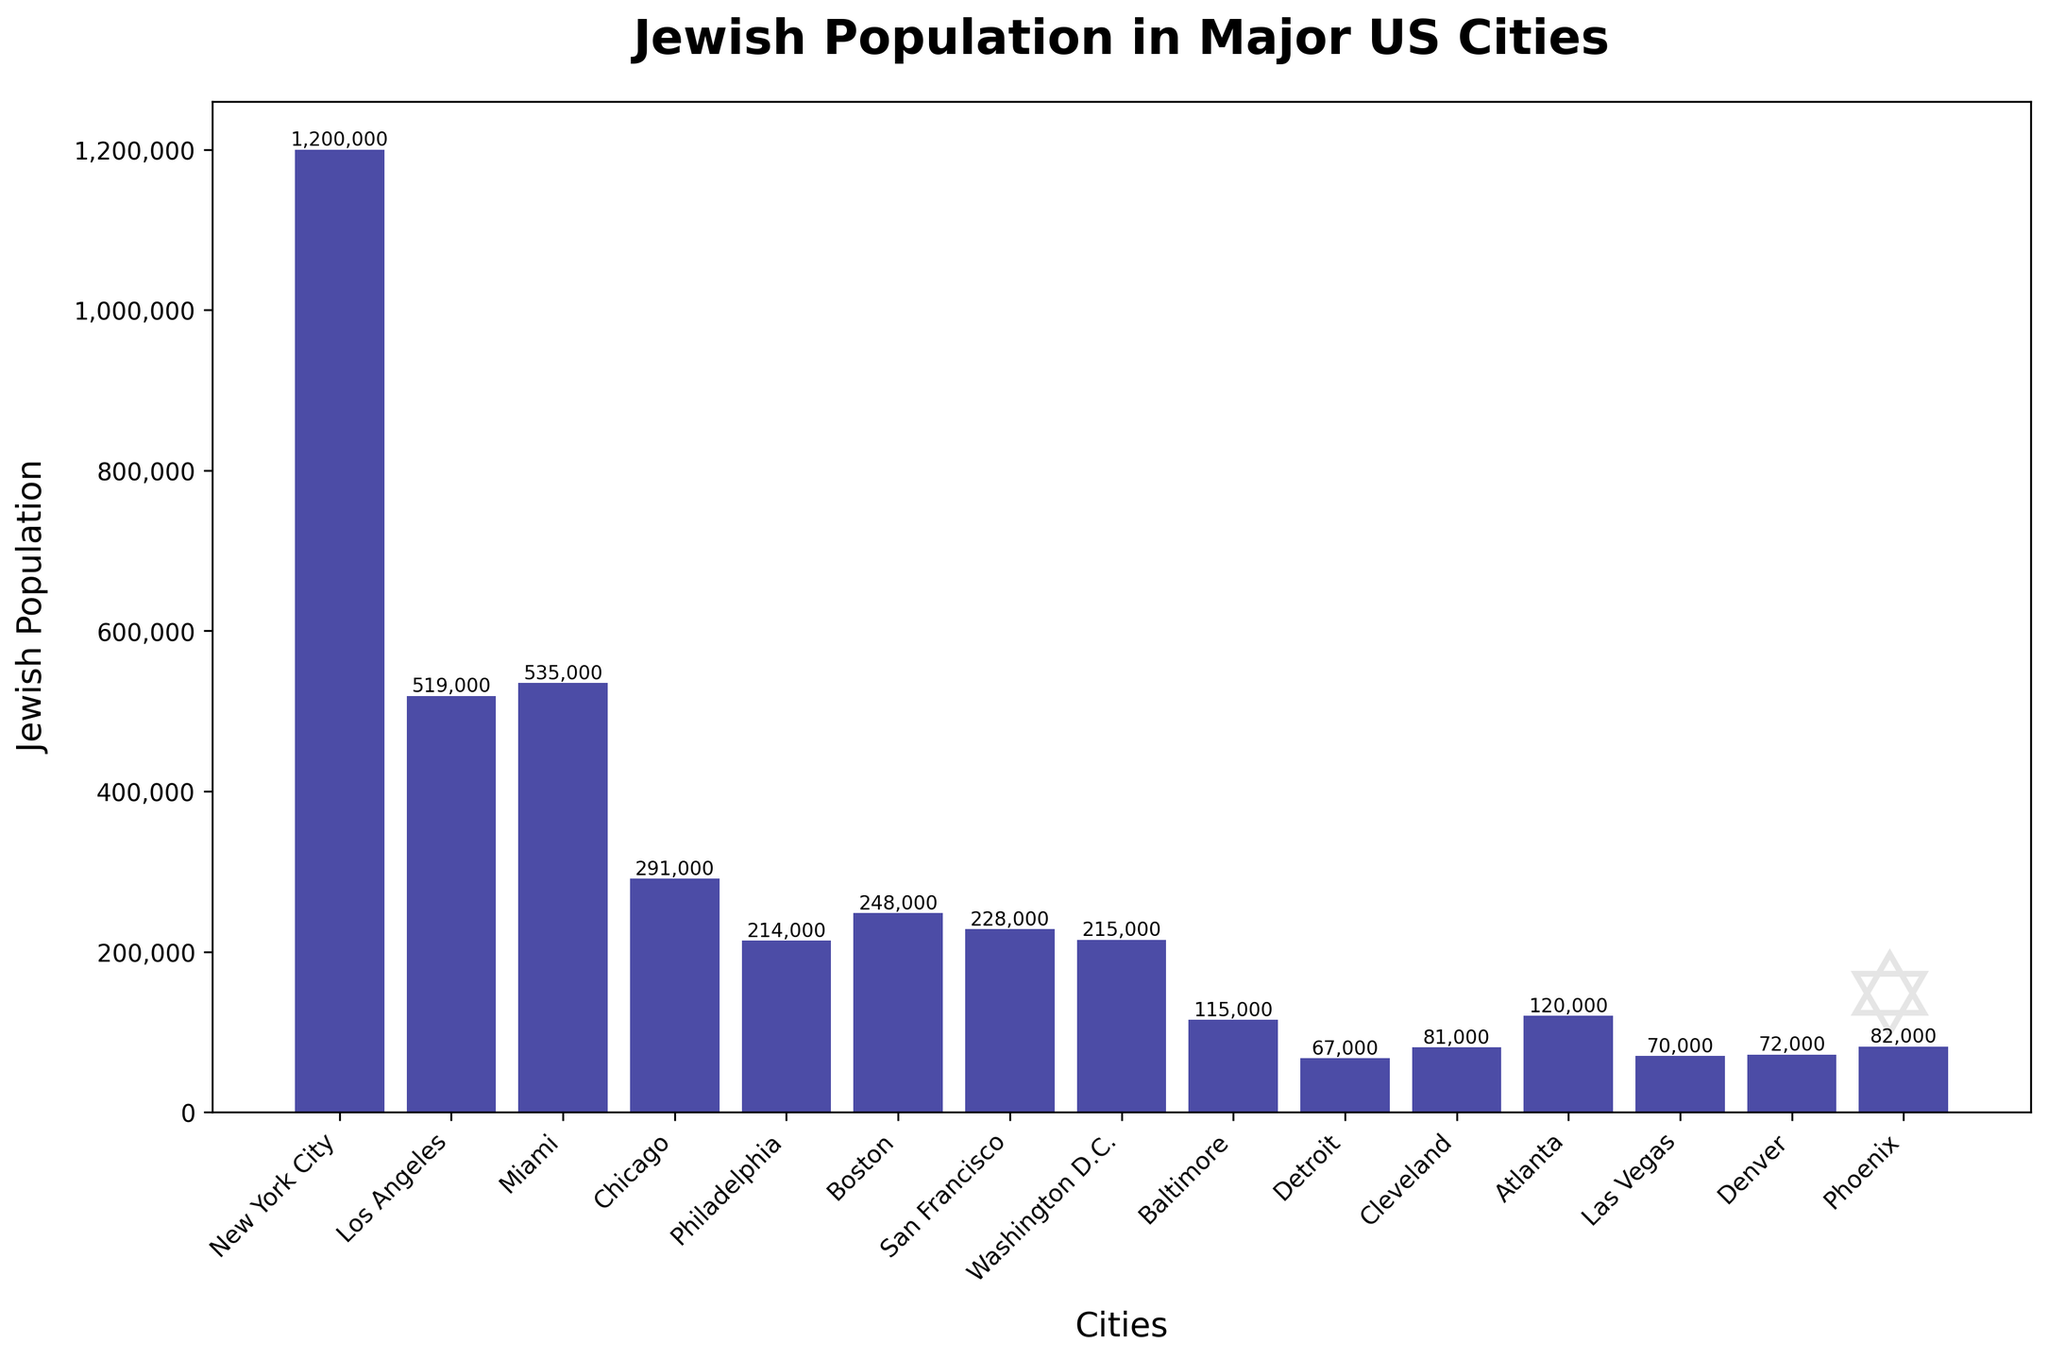what is the total Jewish population in New York City and Los Angeles? Add the Jewish population of New York City and Los Angeles. New York City has 1,200,000 and Los Angeles has 519,000. So, 1,200,000 + 519,000 gives us the total.
Answer: 1,719,000 which city has a larger Jewish population, Miami or Chicago? Compare the Jewish populations of Miami and Chicago. Miami has 535,000, and Chicago has 291,000. Since 535,000 is greater than 291,000, Miami has the larger population.
Answer: Miami if Boston's Jewish population is decreased by Baltimore's population, what is the result? Subtract Baltimore's Jewish population from Boston's Jewish population. Boston has 248,000 and Baltimore has 115,000. Therefore, 248,000 - 115,000 gives us the result.
Answer: 133,000 which city has the smallest Jewish population and what is it? Identify the city with the smallest Jewish population from the data provided. The cities and populations are compared, and Detroit has 67,000, which is the smallest value.
Answer: Detroit, 67,000 what is the average Jewish population of the cities listed? Sum all the Jewish populations of the cities listed and then divide by the number of cities. The total population is 3,305,000 and there are 15 cities. 3,305,000 / 15 gives an average.
Answer: 220,333 which city has just slightly more Jewish population than Atlanta? Identify the Jewish population of Atlanta, which is 120,000, and find the city with the population closest but slightly more. Philadelphia, with 214,000, is directly higher, and no city lies between these two values.
Answer: Philadelphia which three cities have the highest Jewish populations and what are their populations? List the top three cities with the highest Jewish populations from the data. New York City has 1,200,000, Miami has 535,000, and Los Angeles has 519,000. These are the top three.
Answer: New York City: 1,200,000, Miami: 535,000, Los Angeles: 519,000 how much more is the Jewish population in New York City compared to Boston? Find the difference between the Jewish population of New York City and Boston. New York City has 1,200,000 and Boston has 248,000, so 1,200,000 - 248,000 gives us the difference.
Answer: 952,000 what is the combined Jewish population of the smallest four cities listed? Add the Jewish populations of the four smallest cities. The smallest cities are Detroit (67,000), Las Vegas (70,000), Denver (72,000), and Cleveland (81,000). 67,000 + 70,000 + 72,000 + 81,000 gives us the total.
Answer: 290,000 